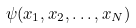Convert formula to latex. <formula><loc_0><loc_0><loc_500><loc_500>\psi ( x _ { 1 } , x _ { 2 } , \dots , x _ { N } )</formula> 